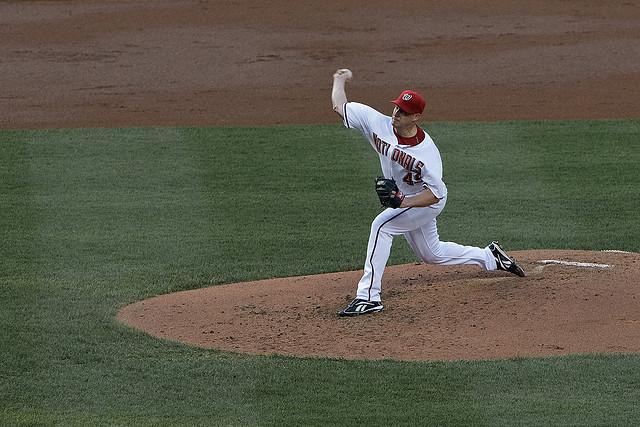Which person does not hit the ball in this game?
Be succinct. Pitcher. Is the man wearing Nike shoes?
Quick response, please. No. Who does he play for?
Short answer required. Nationals. Is the player ready to run?
Concise answer only. No. What color is the hat?
Answer briefly. Red. Did the batter just hit the ball?
Write a very short answer. No. Is the man sliding?
Give a very brief answer. No. What team does he play for?
Answer briefly. Cardinals. Is the ball in motion?
Concise answer only. Yes. Has the baseball been pitched?
Quick response, please. No. What is the area called where the pitcher is standing?
Answer briefly. Mound. What is the man in the Red Hat holding?
Write a very short answer. Baseball. What is the man throwing?
Quick response, please. Baseball. 